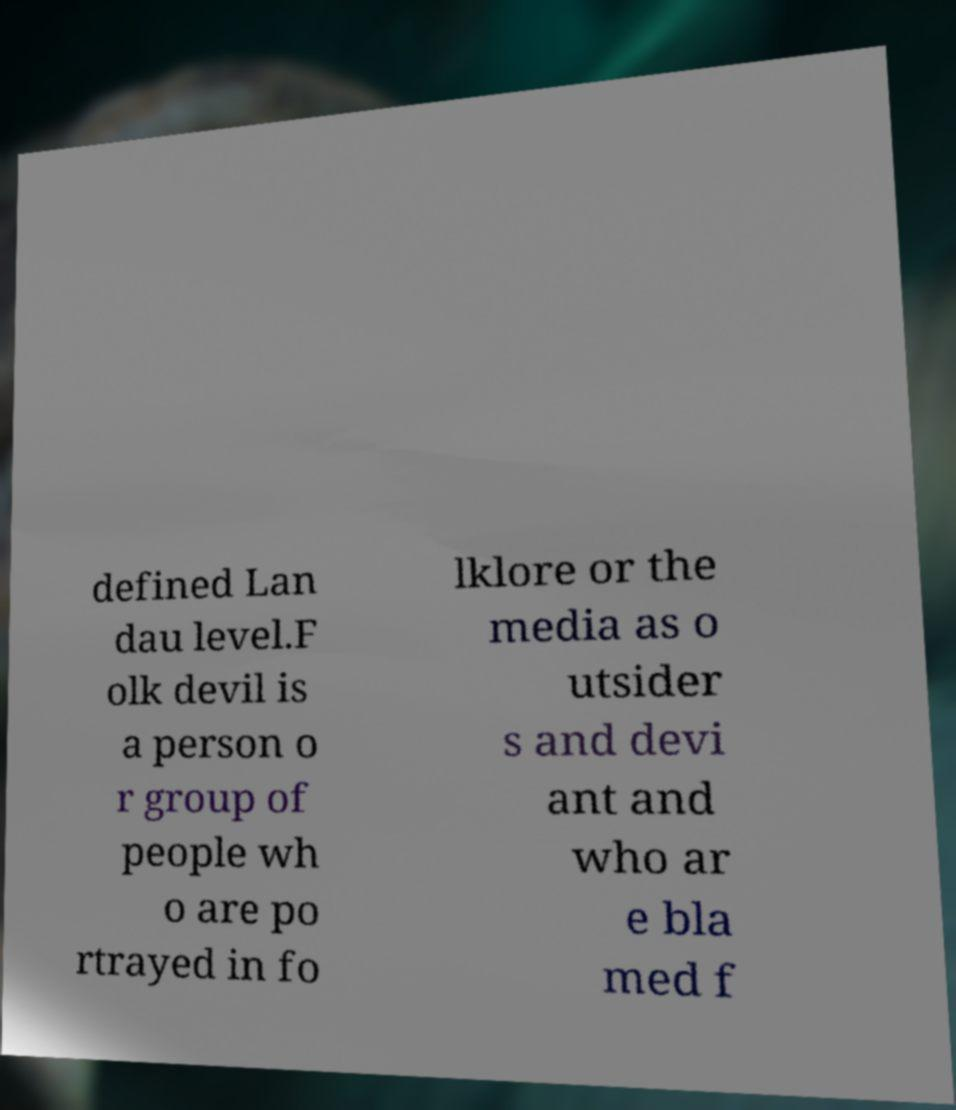Can you read and provide the text displayed in the image?This photo seems to have some interesting text. Can you extract and type it out for me? defined Lan dau level.F olk devil is a person o r group of people wh o are po rtrayed in fo lklore or the media as o utsider s and devi ant and who ar e bla med f 